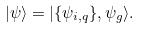<formula> <loc_0><loc_0><loc_500><loc_500>| \psi \rangle = | \{ \psi _ { i , { q } } \} , \psi _ { g } \rangle .</formula> 